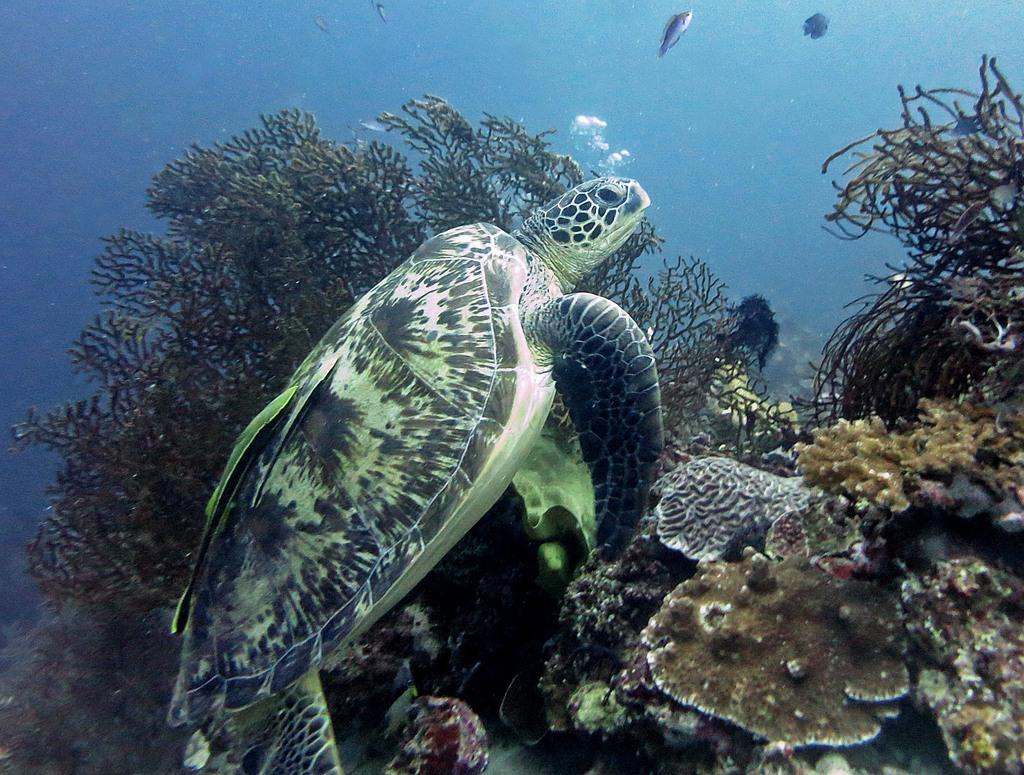Where was the image taken? The image is taken under the sea. What can be seen in the water in the image? There are coral reefs and fishes visible in the water. What is the main subject in the middle of the image? There is a tortoise in the middle of the image. What type of roof can be seen on the coral reefs in the image? There is no roof present in the image, as it is taken under the sea and features coral reefs and marine life. 